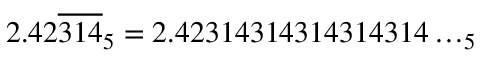Convert formula to latex. <formula><loc_0><loc_0><loc_500><loc_500>2 . 4 2 { \overline { 3 1 4 } } _ { 5 } = 2 . 4 2 3 1 4 3 1 4 3 1 4 3 1 4 3 1 4 \dots _ { 5 }</formula> 